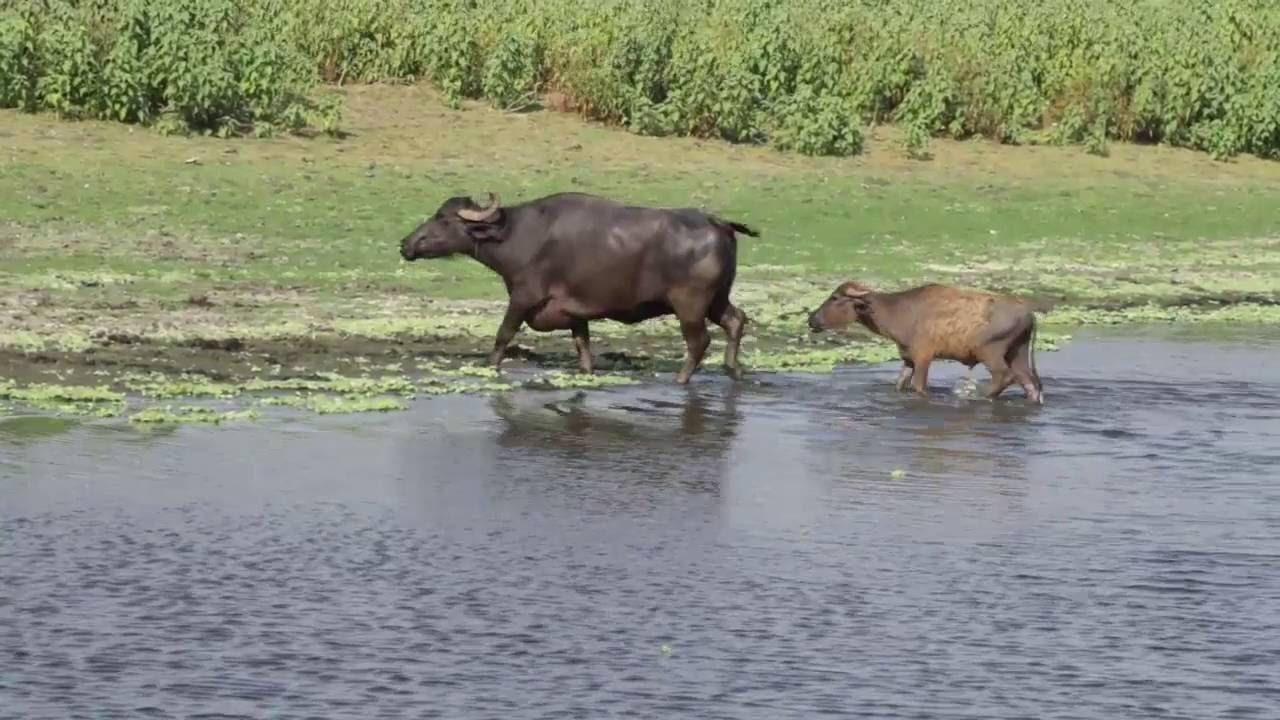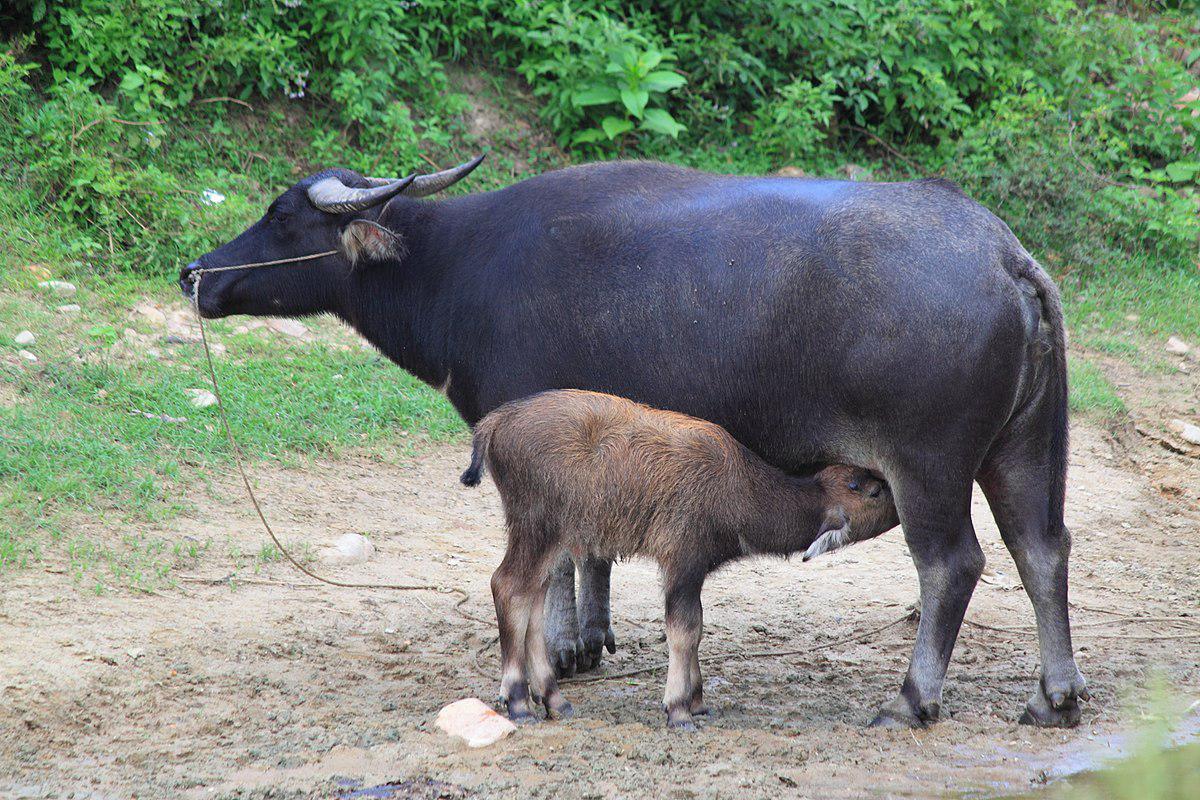The first image is the image on the left, the second image is the image on the right. Considering the images on both sides, is "An ox is being ridden by at least one picture in all images." valid? Answer yes or no. No. The first image is the image on the left, the second image is the image on the right. Examine the images to the left and right. Is the description "At least two people are riding together on the back of one horned animal in a scene." accurate? Answer yes or no. No. 